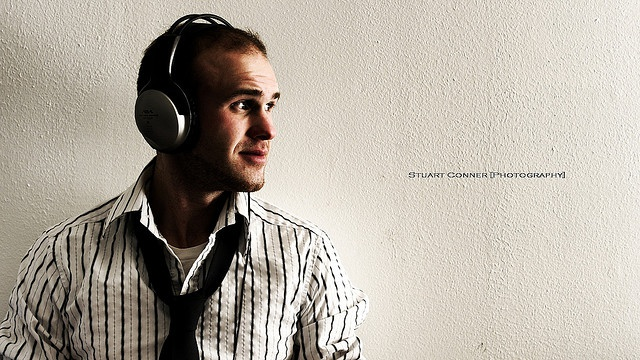Describe the objects in this image and their specific colors. I can see people in lightgray, black, white, darkgray, and gray tones and tie in lightgray, black, gray, white, and darkgray tones in this image. 